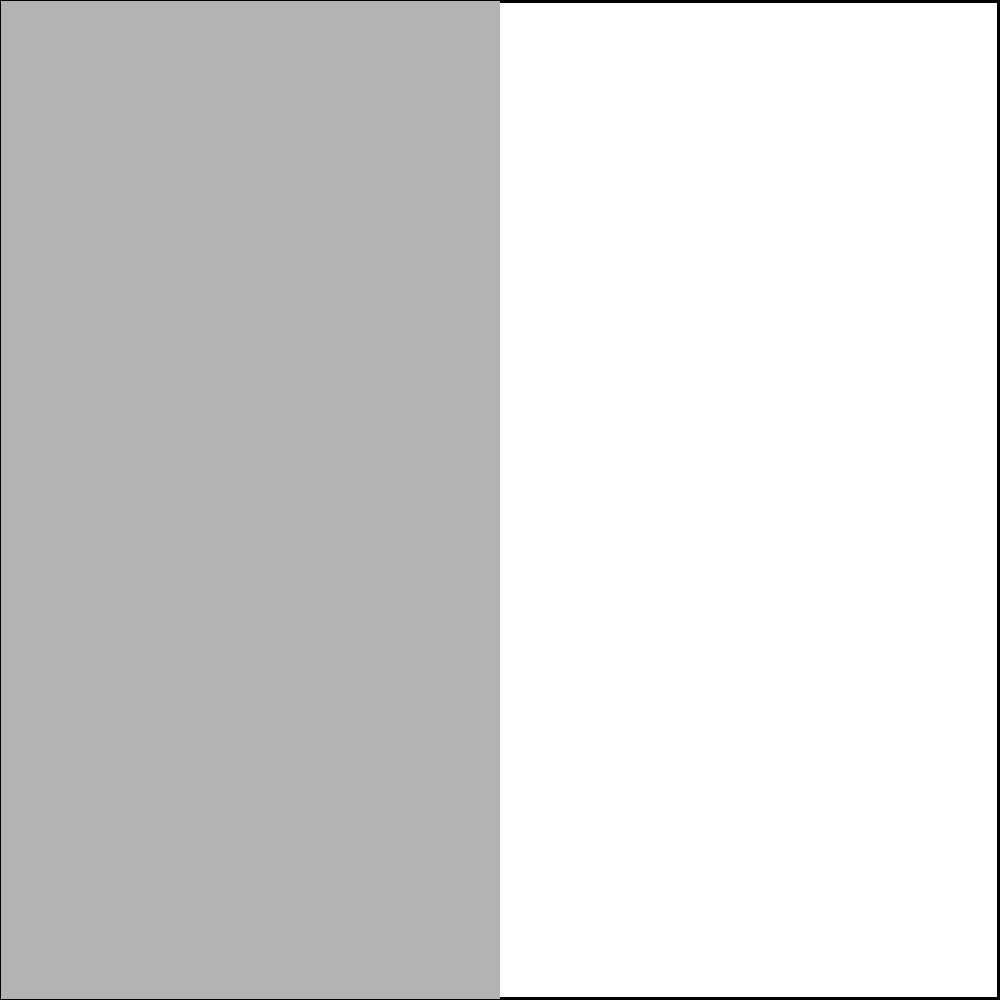A square is divided into two equal parts by a diagonal line. The left half is filled with a smooth texture, while the right half has a hatched pattern. What type of symmetry does this square exhibit along the diagonal line? To determine the type of symmetry exhibited by the square along the diagonal line, let's follow these steps:

1. Understand the concept of symmetry:
   Symmetry occurs when an object remains unchanged after a transformation.

2. Identify the key features of the square:
   - The square is divided into two equal triangular parts by a diagonal line.
   - The left half has a smooth texture.
   - The right half has a hatched pattern.

3. Consider the types of symmetry:
   - Rotational symmetry: The object looks the same after rotation.
   - Reflectional symmetry: The object looks the same when reflected across a line.
   - Translational symmetry: The object looks the same when moved in a straight line.

4. Analyze the square's properties:
   - If we fold the square along the diagonal line, the two halves would align perfectly in shape.
   - However, the textures on each side are different.

5. Apply the concept of reflectional symmetry:
   - Reflectional symmetry requires that one half be a mirror image of the other.
   - In this case, the shapes match, but the textures do not.

6. Conclusion:
   The square does not exhibit true reflectional symmetry along the diagonal line due to the different textures on each side.

Therefore, the square does not have any symmetry along the diagonal line when considering both shape and texture.
Answer: No symmetry 